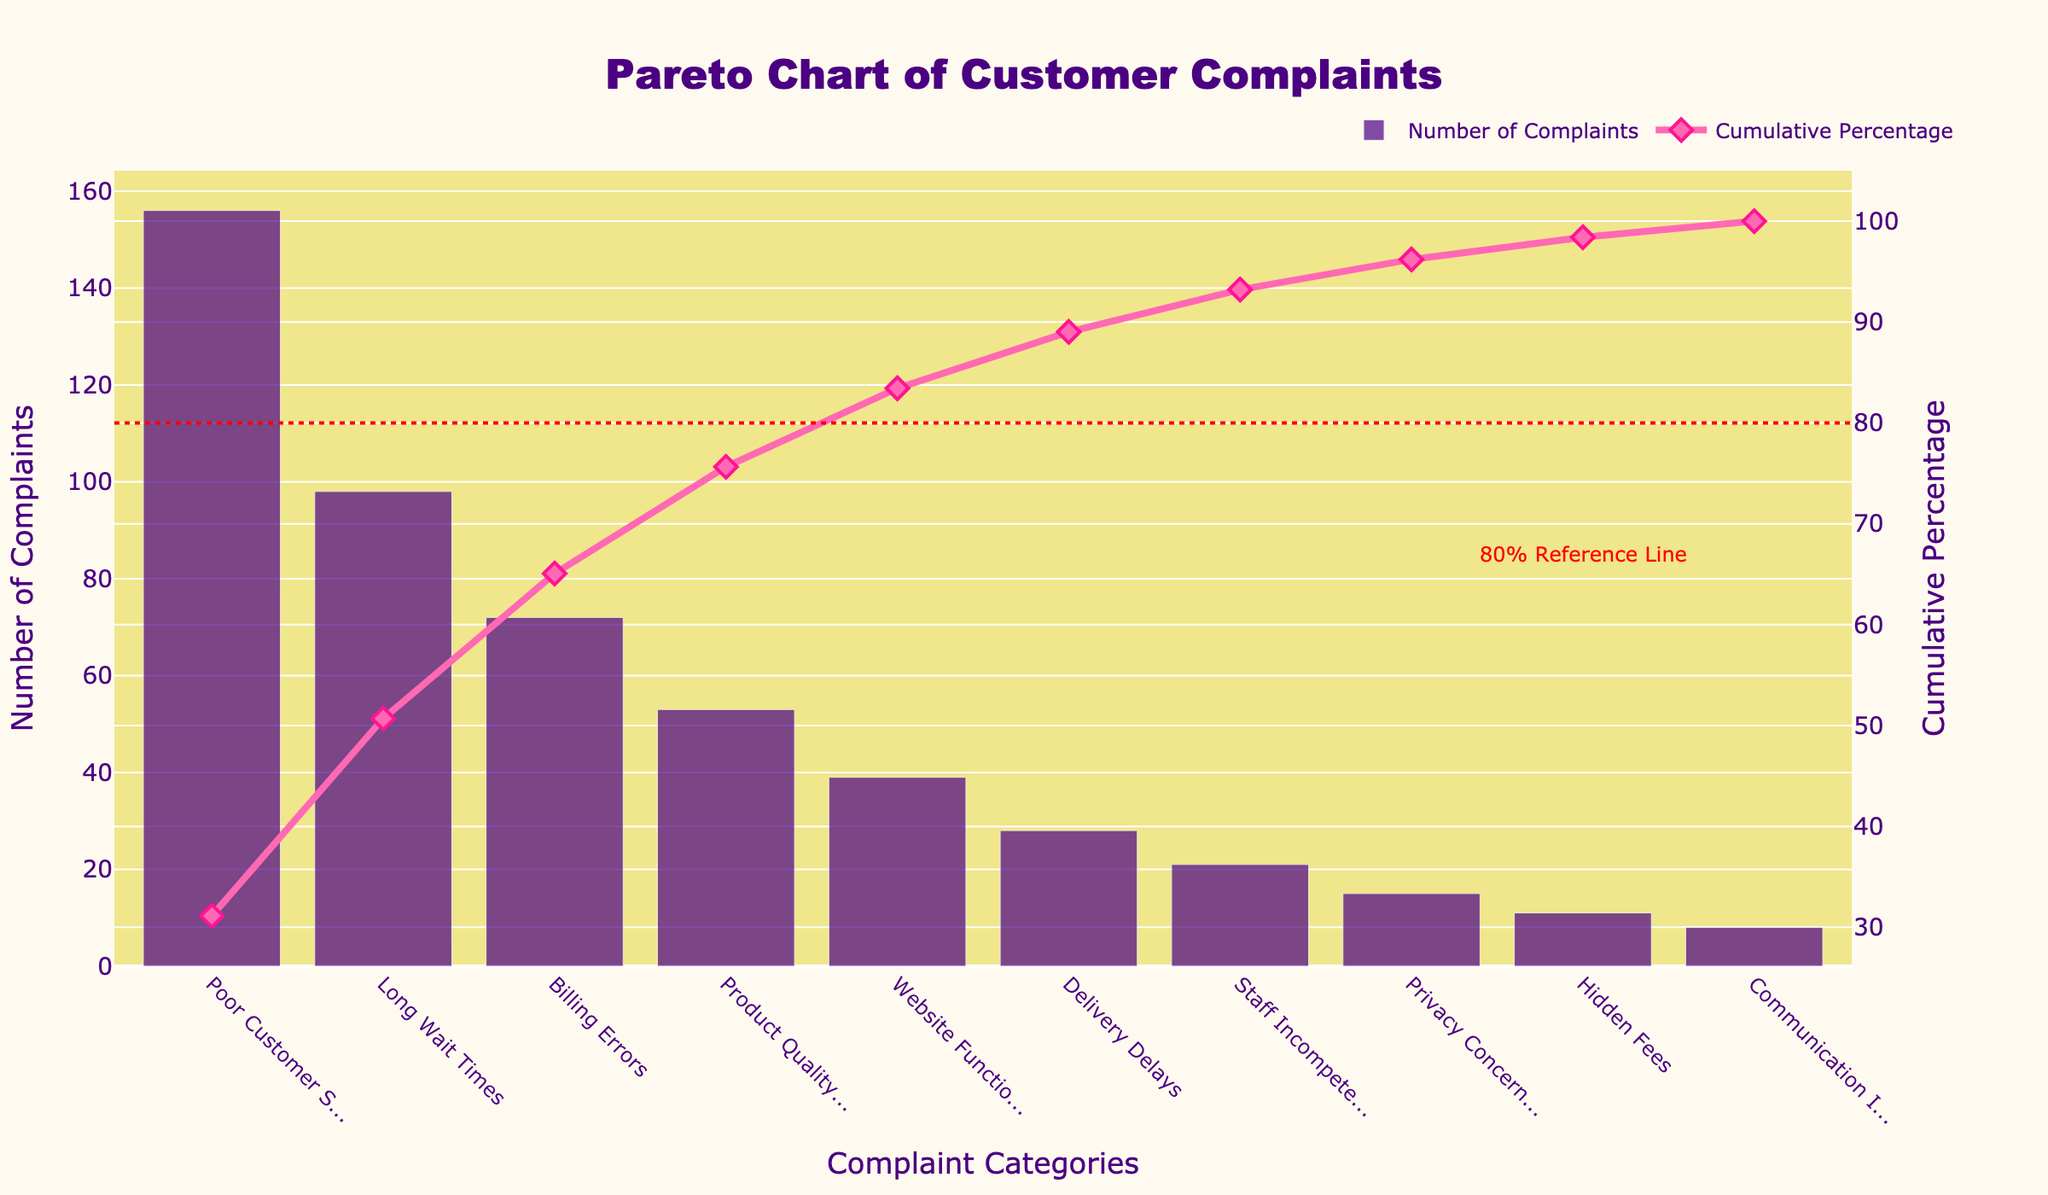What is the title of the chart? The title is located at the top center of the figure. It provides an overview of what the chart represents. In this case, it reads "Pareto Chart of Customer Complaints".
Answer: Pareto Chart of Customer Complaints Which category has the highest number of complaints? The category with the highest number of complaints can be identified by looking at the tallest bar in the bar chart. Here, "Poor Customer Service" is the tallest bar.
Answer: Poor Customer Service What is the cumulative percentage of complaints for the top three categories? To find this, look at the line representing the cumulative percentage and sum up the percentages for the top three bars. The top three categories are "Poor Customer Service", "Long Wait Times", and "Billing Errors". Using the cumulative percentage values for these categories, you can see that the top three sum up to around 66.6%.
Answer: Around 66.6% How many categories fall under the 80% cumulative percentage line? The 80% reference line is marked on the right y-axis. Count the categories up to the point where the cumulative line crosses the 80% mark. Here, it is up until "Product Quality Issues", making it four categories.
Answer: 4 categories Which category contributes to the smallest percentage of the total complaints? Look for the shortest bar in the bar chart. "Communication Issues" has the shortest bar, indicating the smallest number of complaints.
Answer: Communication Issues What percentage of the total complaints does the largest category represent? The cumulative percentage for the first category "Poor Customer Service" provides this information directly. From the chart, it shows about 30.4%.
Answer: About 30.4% What is the difference in the number of complaints between "Poor Customer Service" and "Product Quality Issues"? Subtract the number of complaints for "Product Quality Issues" from "Poor Customer Service". With 156 complaints for "Poor Customer Service" and 53 for "Product Quality Issues", the difference is 156 - 53 = 103.
Answer: 103 What do the colors and markers represent in the chart? The bar chart is colored in dark purple, representing the number of complaints for each category. The line chart uses a pink color with diamond markers to indicate the cumulative percentage of complaints.
Answer: Dark purple bars represent complaints, pink line with diamond markers represents cumulative percentage How do "Staff Incompetence" and "Delivery Delays" compare in terms of the number of complaints? Compare the heights of the bars for these two categories. "Delivery Delays" has 28 complaints and "Staff Incompetence" has 21. Therefore, "Delivery Delays" has more complaints.
Answer: Delivery Delays has more complaints What is the combined number of complaints for "Website Functionality" and "Hidden Fees"? Add the number of complaints for these two categories. "Website Functionality" has 39 complaints, and "Hidden Fees" has 11. Thus, the total is 39 + 11 = 50.
Answer: 50 